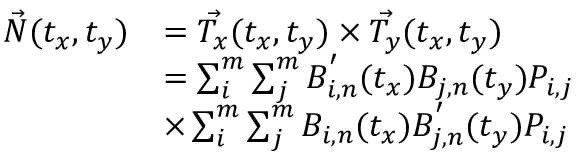Convert formula to latex. <formula><loc_0><loc_0><loc_500><loc_500>\begin{array} { r l } { \vec { N } ( t _ { x } , t _ { y } ) } & { = \vec { T _ { x } } ( t _ { x } , t _ { y } ) \times \vec { T _ { y } } ( t _ { x } , t _ { y } ) } \\ & { = \sum _ { i } ^ { m } { \sum _ { j } ^ { m } { B _ { i , n } ^ { ^ { \prime } } ( t _ { x } ) B _ { j , n } ( t _ { y } ) P _ { i , j } } } } \\ & { \times \sum _ { i } ^ { m } { \sum _ { j } ^ { m } { B _ { i , n } ( t _ { x } ) B _ { j , n } ^ { ^ { \prime } } ( t _ { y } ) P _ { i , j } } } } \end{array}</formula> 